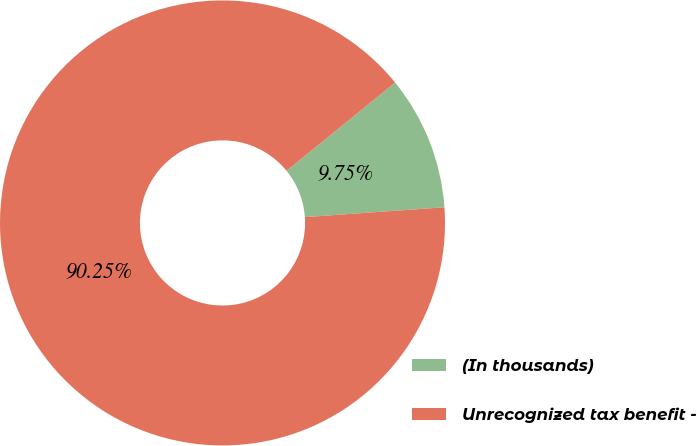Convert chart to OTSL. <chart><loc_0><loc_0><loc_500><loc_500><pie_chart><fcel>(In thousands)<fcel>Unrecognized tax benefit -<nl><fcel>9.75%<fcel>90.25%<nl></chart> 